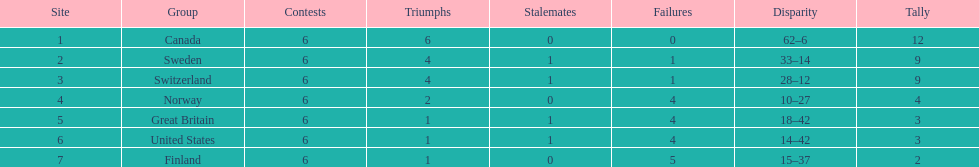How many teams won at least 2 games throughout the 1951 world ice hockey championships? 4. 